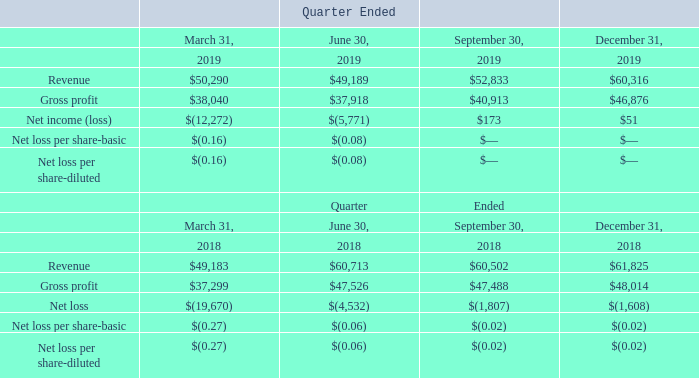14. Selected Quarterly Financial Data (Unaudited)
Selected quarterly financial data for 2019 and 2018 is as follows (in thousands, except per share amounts):
What type of data is shown in the table? Selected quarterly financial data for 2019 and 2018. What is the revenue earned in the first quarter of 2019?
Answer scale should be: thousand. $50,290. What is the revenue earned in the second quarter of 2019?
Answer scale should be: thousand. $49,189. What is the change in revenue between the first and second quarters of 2019?
Answer scale should be: percent. ($50,290 - $49,189)/$49,189 
Answer: 2.24. What is the change in gross profit between the second and third quarter of 2018?
Answer scale should be: percent. ($47,526 - $47,488)/$47,488 
Answer: 0.08. What is the difference in revenue between December 31,2018 to December 31,2019?
Answer scale should be: thousand. $60,316-$61,825
Answer: -1509. 